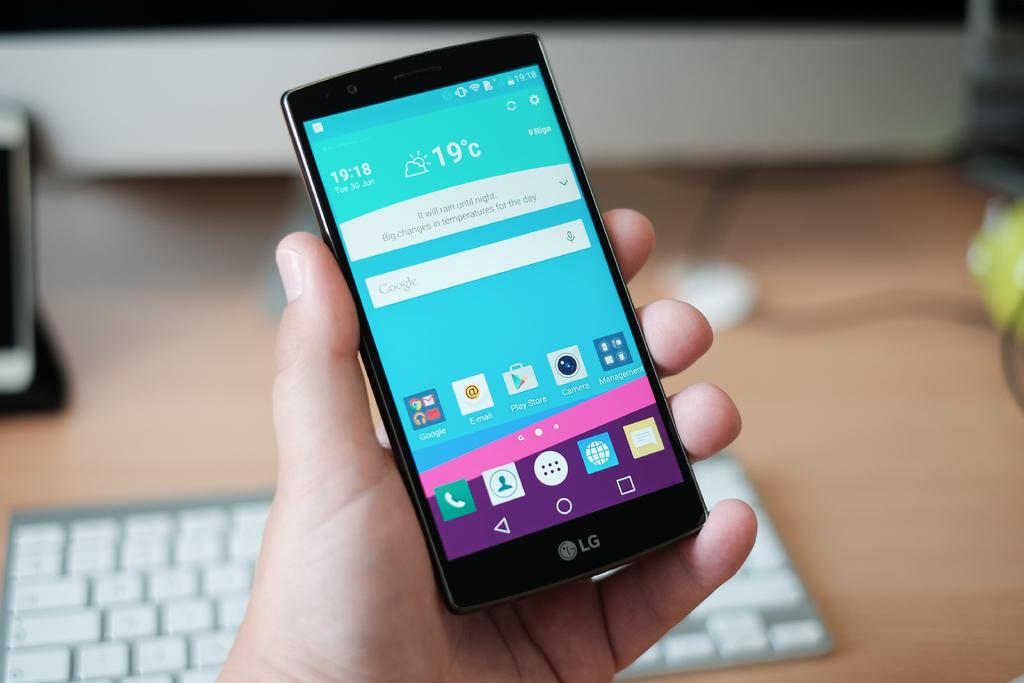Provide a one-sentence caption for the provided image. A hand holding a black phone with the weather pulled up and a keyboard is also beneath the hand. 